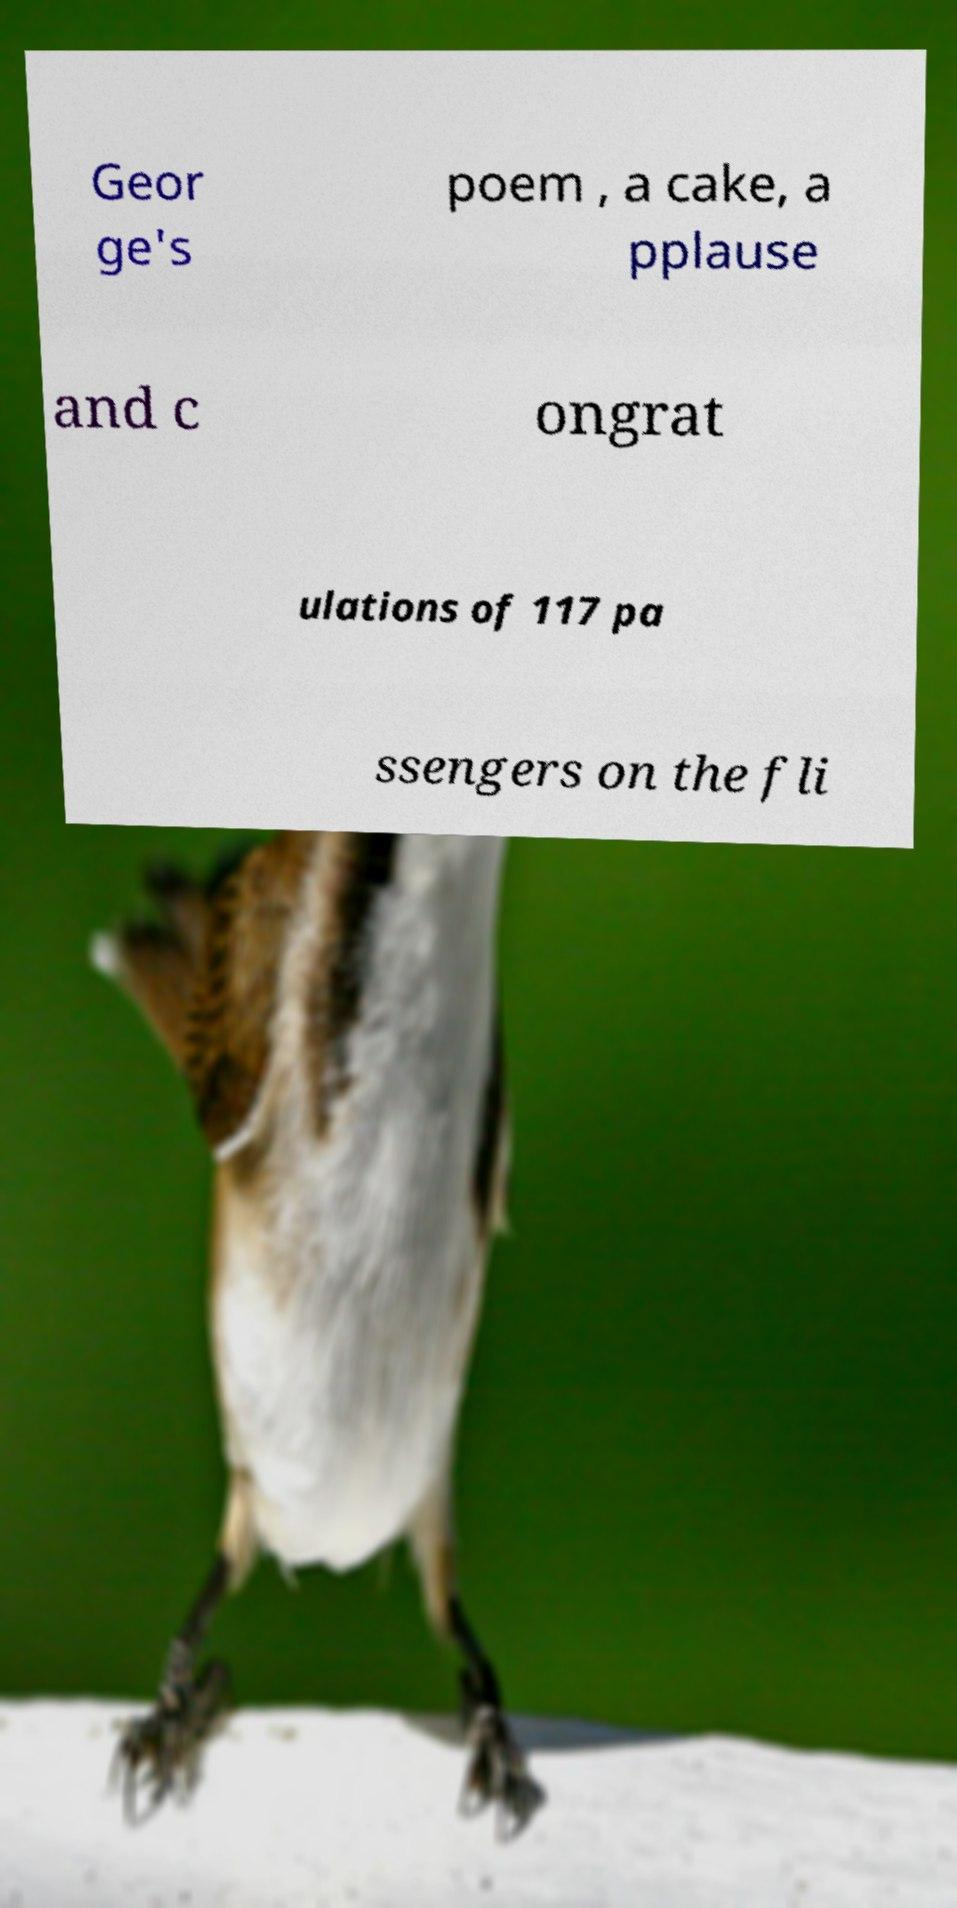What messages or text are displayed in this image? I need them in a readable, typed format. Geor ge's poem , a cake, a pplause and c ongrat ulations of 117 pa ssengers on the fli 